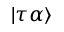<formula> <loc_0><loc_0><loc_500><loc_500>| \tau \alpha \rangle</formula> 